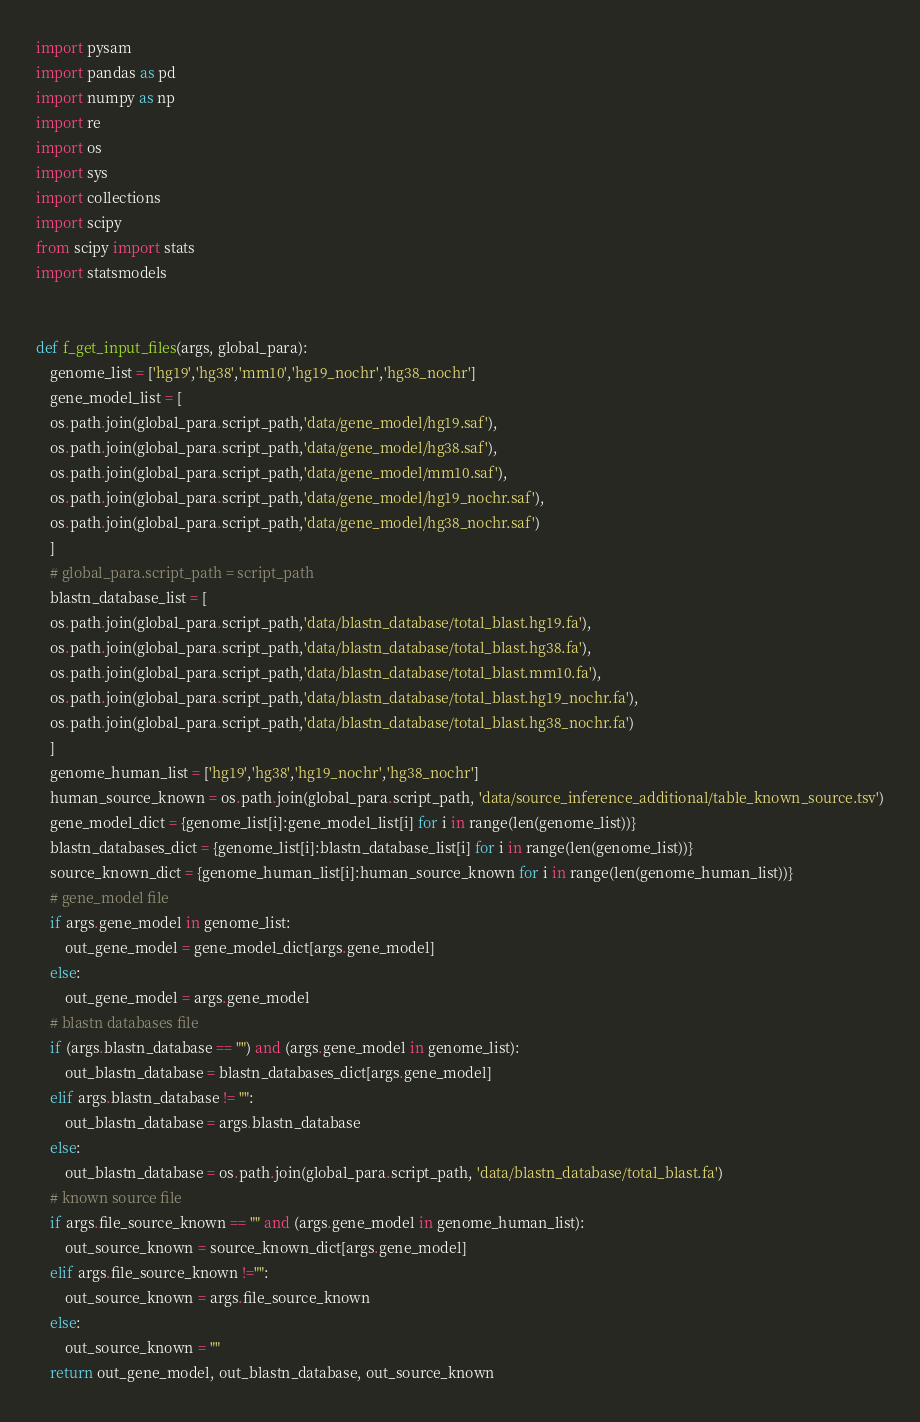<code> <loc_0><loc_0><loc_500><loc_500><_Python_>import pysam
import pandas as pd
import numpy as np
import re
import os
import sys
import collections
import scipy
from scipy import stats
import statsmodels


def f_get_input_files(args, global_para):
    genome_list = ['hg19','hg38','mm10','hg19_nochr','hg38_nochr']
    gene_model_list = [
    os.path.join(global_para.script_path,'data/gene_model/hg19.saf'),
    os.path.join(global_para.script_path,'data/gene_model/hg38.saf'),
    os.path.join(global_para.script_path,'data/gene_model/mm10.saf'),
    os.path.join(global_para.script_path,'data/gene_model/hg19_nochr.saf'),
    os.path.join(global_para.script_path,'data/gene_model/hg38_nochr.saf')
    ]
    # global_para.script_path = script_path
    blastn_database_list = [
    os.path.join(global_para.script_path,'data/blastn_database/total_blast.hg19.fa'),
    os.path.join(global_para.script_path,'data/blastn_database/total_blast.hg38.fa'),
    os.path.join(global_para.script_path,'data/blastn_database/total_blast.mm10.fa'),
    os.path.join(global_para.script_path,'data/blastn_database/total_blast.hg19_nochr.fa'),
    os.path.join(global_para.script_path,'data/blastn_database/total_blast.hg38_nochr.fa')
    ]
    genome_human_list = ['hg19','hg38','hg19_nochr','hg38_nochr']
    human_source_known = os.path.join(global_para.script_path, 'data/source_inference_additional/table_known_source.tsv')
    gene_model_dict = {genome_list[i]:gene_model_list[i] for i in range(len(genome_list))}
    blastn_databases_dict = {genome_list[i]:blastn_database_list[i] for i in range(len(genome_list))}
    source_known_dict = {genome_human_list[i]:human_source_known for i in range(len(genome_human_list))}
    # gene_model file
    if args.gene_model in genome_list:
        out_gene_model = gene_model_dict[args.gene_model]
    else:
        out_gene_model = args.gene_model
    # blastn databases file
    if (args.blastn_database == "") and (args.gene_model in genome_list):
        out_blastn_database = blastn_databases_dict[args.gene_model]
    elif args.blastn_database != "":
        out_blastn_database = args.blastn_database
    else:
        out_blastn_database = os.path.join(global_para.script_path, 'data/blastn_database/total_blast.fa')
    # known source file
    if args.file_source_known == "" and (args.gene_model in genome_human_list):
        out_source_known = source_known_dict[args.gene_model]
    elif args.file_source_known !="":
        out_source_known = args.file_source_known
    else:
        out_source_known = ""
    return out_gene_model, out_blastn_database, out_source_known


</code> 